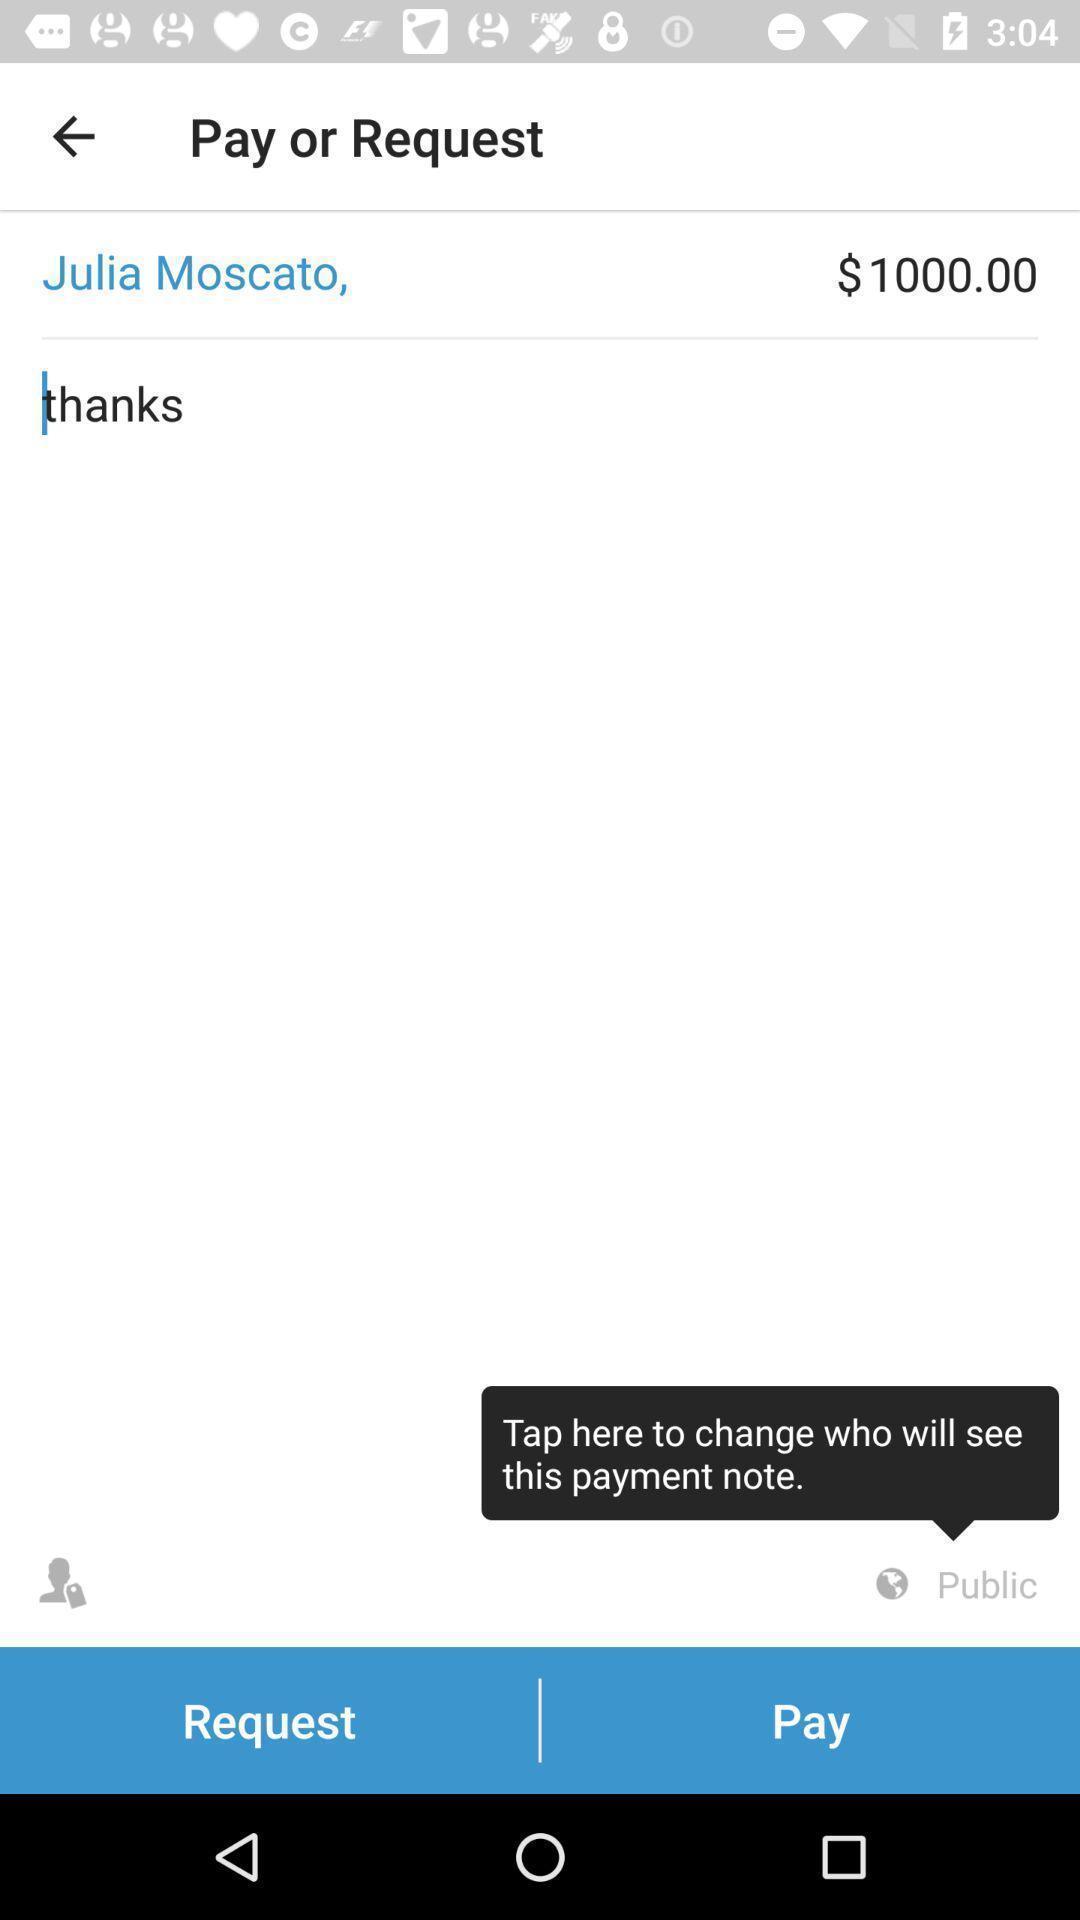Tell me what you see in this picture. Screen displaying the page of a payment app. 